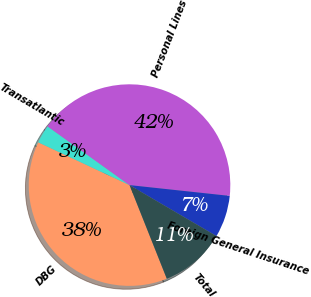Convert chart. <chart><loc_0><loc_0><loc_500><loc_500><pie_chart><fcel>DBG<fcel>Transatlantic<fcel>Personal Lines<fcel>Foreign General Insurance<fcel>Total<nl><fcel>38.01%<fcel>2.92%<fcel>41.81%<fcel>6.73%<fcel>10.53%<nl></chart> 